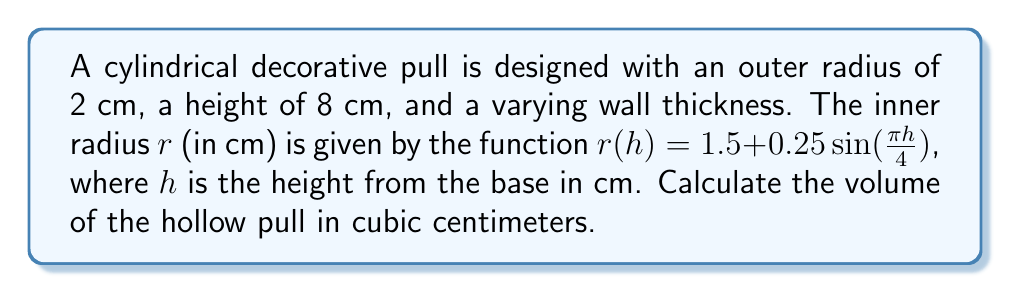Give your solution to this math problem. To find the volume of the hollow pull, we need to:

1. Calculate the volume of the entire cylinder
2. Calculate the volume of the inner hollow part
3. Subtract the inner volume from the total volume

Step 1: Volume of the entire cylinder
$$V_{total} = \pi R^2 h = \pi (2\text{ cm})^2 (8\text{ cm}) = 32\pi \text{ cm}^3$$

Step 2: Volume of the inner hollow part
We need to use the formula for the volume of a solid of revolution:
$$V_{inner} = \int_0^8 \pi r(h)^2 dh$$

Substituting the function for $r(h)$:
$$V_{inner} = \int_0^8 \pi (1.5 + 0.25\sin(\frac{\pi h}{4}))^2 dh$$

Expanding the squared term:
$$V_{inner} = \pi \int_0^8 (2.25 + 0.75\sin(\frac{\pi h}{4}) + 0.0625\sin^2(\frac{\pi h}{4})) dh$$

Integrating term by term:
$$V_{inner} = \pi [2.25h - \frac{3}{\pi}\cos(\frac{\pi h}{4}) + \frac{h}{2} - \frac{1}{8\pi}\sin(\frac{\pi h}{2})]_0^8$$

Evaluating the integral:
$$V_{inner} = \pi (18 - \frac{3}{\pi}(1-1) + 4 - \frac{1}{8\pi}(0-0)) = 22\pi \text{ cm}^3$$

Step 3: Volume of the hollow pull
$$V_{hollow} = V_{total} - V_{inner} = 32\pi \text{ cm}^3 - 22\pi \text{ cm}^3 = 10\pi \text{ cm}^3$$
Answer: $10\pi \text{ cm}^3$ 